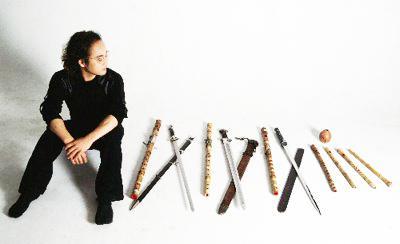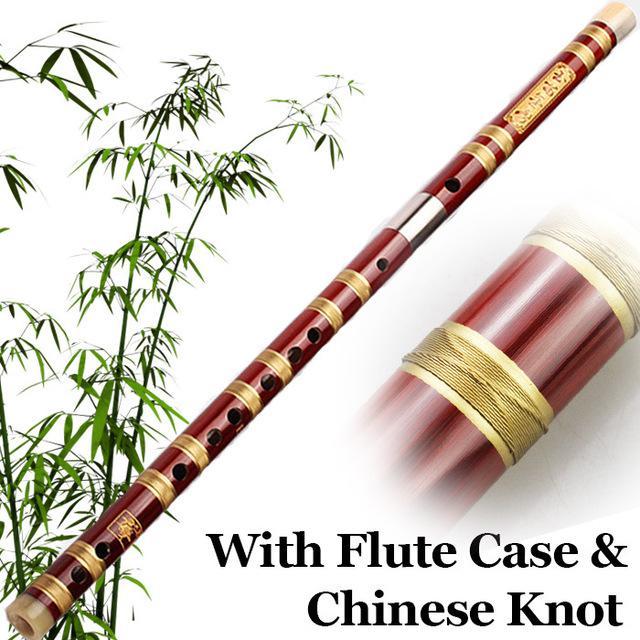The first image is the image on the left, the second image is the image on the right. For the images shown, is this caption "There appears to be four flutes." true? Answer yes or no. No. The first image is the image on the left, the second image is the image on the right. Examine the images to the left and right. Is the description "Three or fewer flutes are visible." accurate? Answer yes or no. No. 